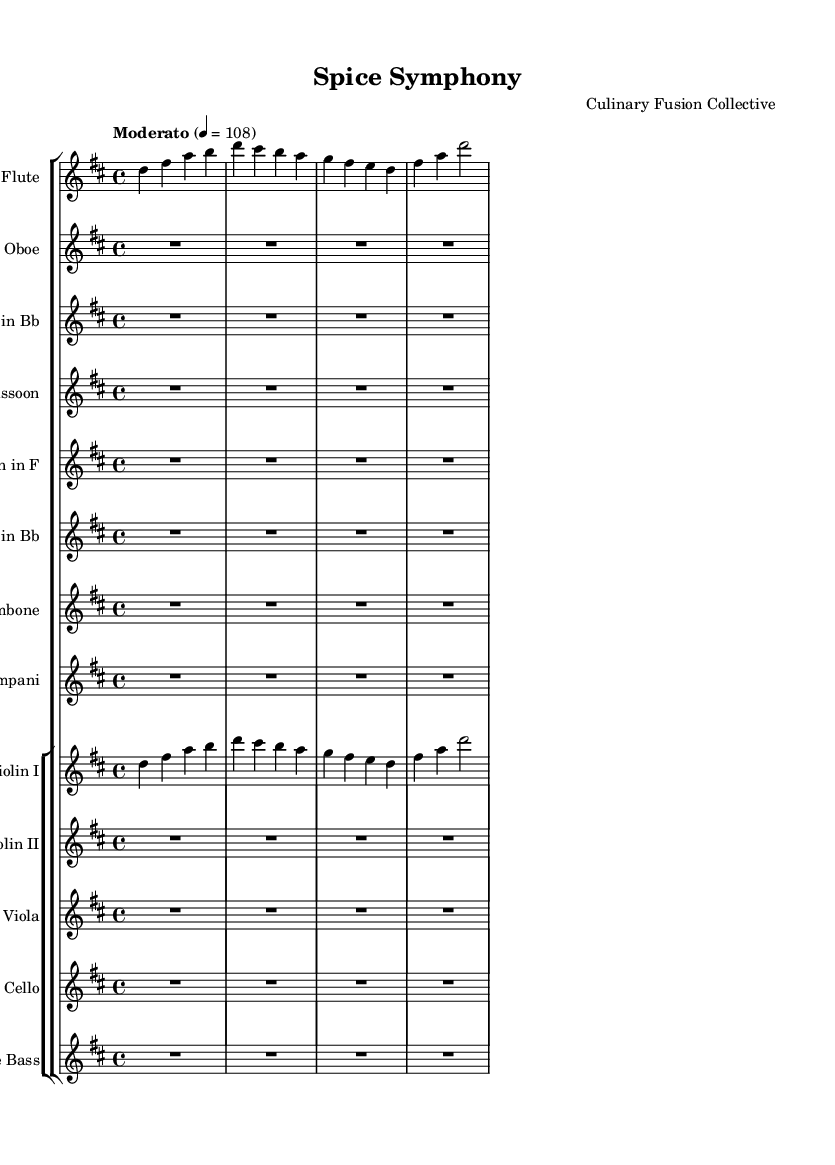What is the key signature of this music? The key signature is indicated at the beginning of the sheet music, which shows two sharps (F# and C#). This identifies the key as D major or B minor.
Answer: D major What is the time signature of this music? The time signature is specified in the beginning section of the music sheet, appearing as 4/4, which means there are four beats in each measure.
Answer: 4/4 What is the tempo marking of this piece? The tempo is indicated below the title, marked as "Moderato" with a metronome marking of 108, which suggests a moderate speed for the piece.
Answer: Moderato, 108 How many measures does the flute part have? By counting the bars in the flute part, we see there are 4 measures indicated in the notation, providing the structure of the music.
Answer: 4 measures Which instruments are indicated to play in the first section? The first section of the score lists several instruments, including Flute, Oboe, Clarinet in Bb, Bassoon, Horn in F, Trumpet in Bb, Trombone, Timpani, and strings such as Violin I and II, Viola, Cello, and Double Bass, indicating a full orchestra.
Answer: Flute, Oboe, Clarinet, Bassoon, Horn, Trumpet, Trombone, Timpani, Violin I, Violin II, Viola, Cello, Double Bass Does the flute part have any rests? Examining the flute part reveals that there are no rests marked, indicating that it plays continuously throughout its specified measures.
Answer: No rests What is the range of the flute part? The flute part starts from D and reaches A in the complete run, indicating that the piece utilizes a range from D5 to A6 without any additional note changes noted.
Answer: D to A 